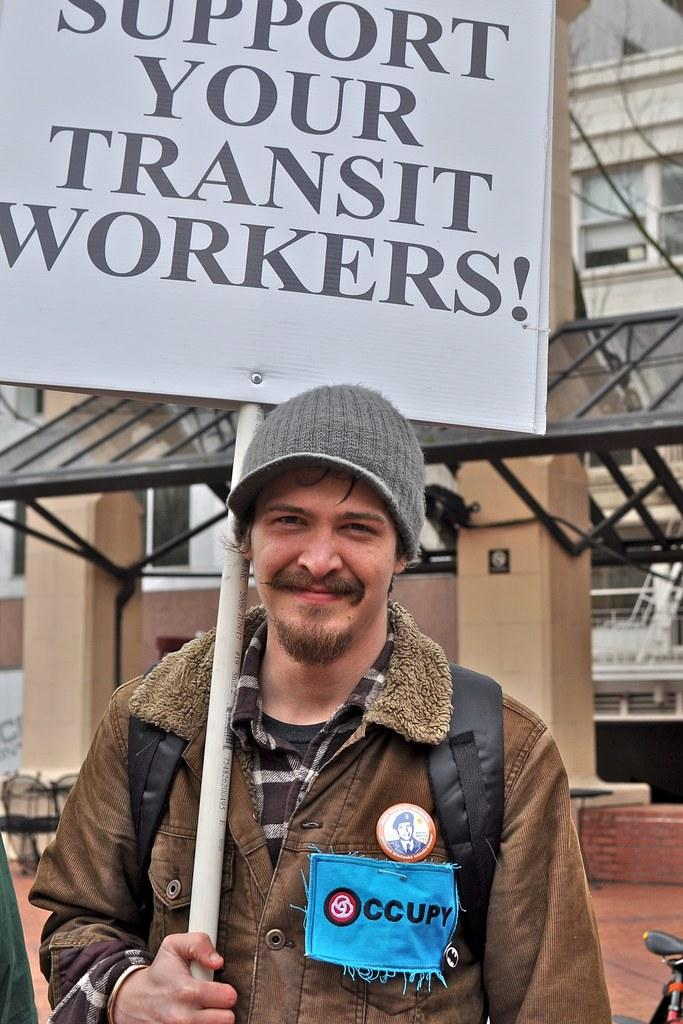What is the man holding in his right hand in the image? The man is holding a placard in his right hand. What type of clothing is the man wearing? The man is wearing a coat. What is the man's facial expression in the image? The man is smiling. What type of headwear is the man wearing? The man is wearing a cap. What can be seen in the background of the image? There is a building behind the man. Who is the man's friend standing next to him in the image? There is no friend visible in the image; the man is alone with the placard. What organization does the man represent in the image? There is no information about the man's affiliation or organization in the image. What type of haircut does the man have in the image? There is no information about the man's haircut in the image. 